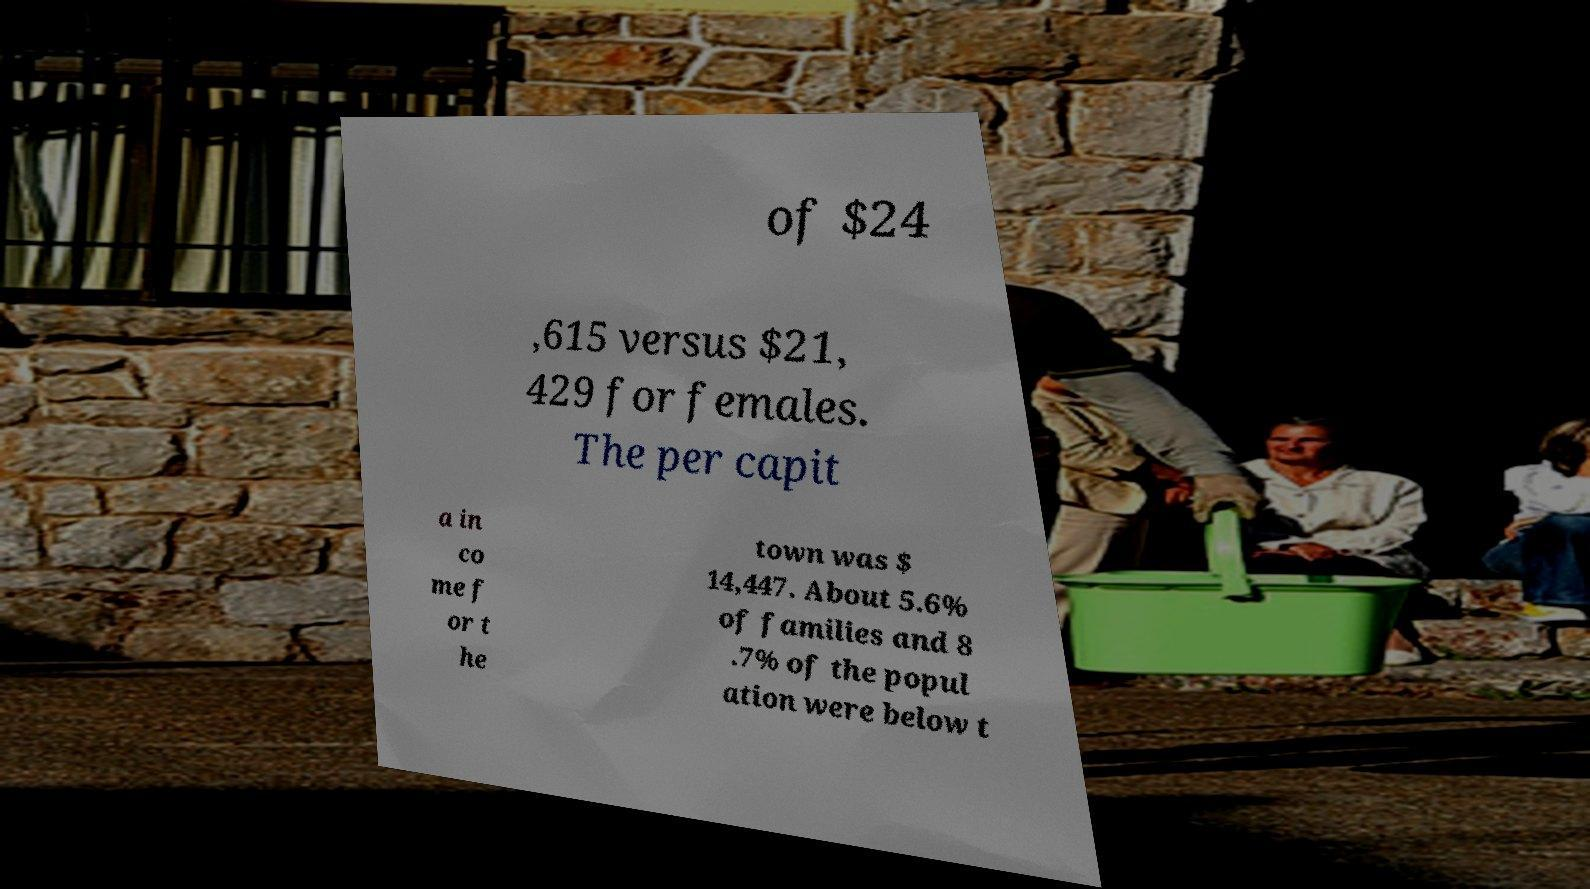There's text embedded in this image that I need extracted. Can you transcribe it verbatim? of $24 ,615 versus $21, 429 for females. The per capit a in co me f or t he town was $ 14,447. About 5.6% of families and 8 .7% of the popul ation were below t 